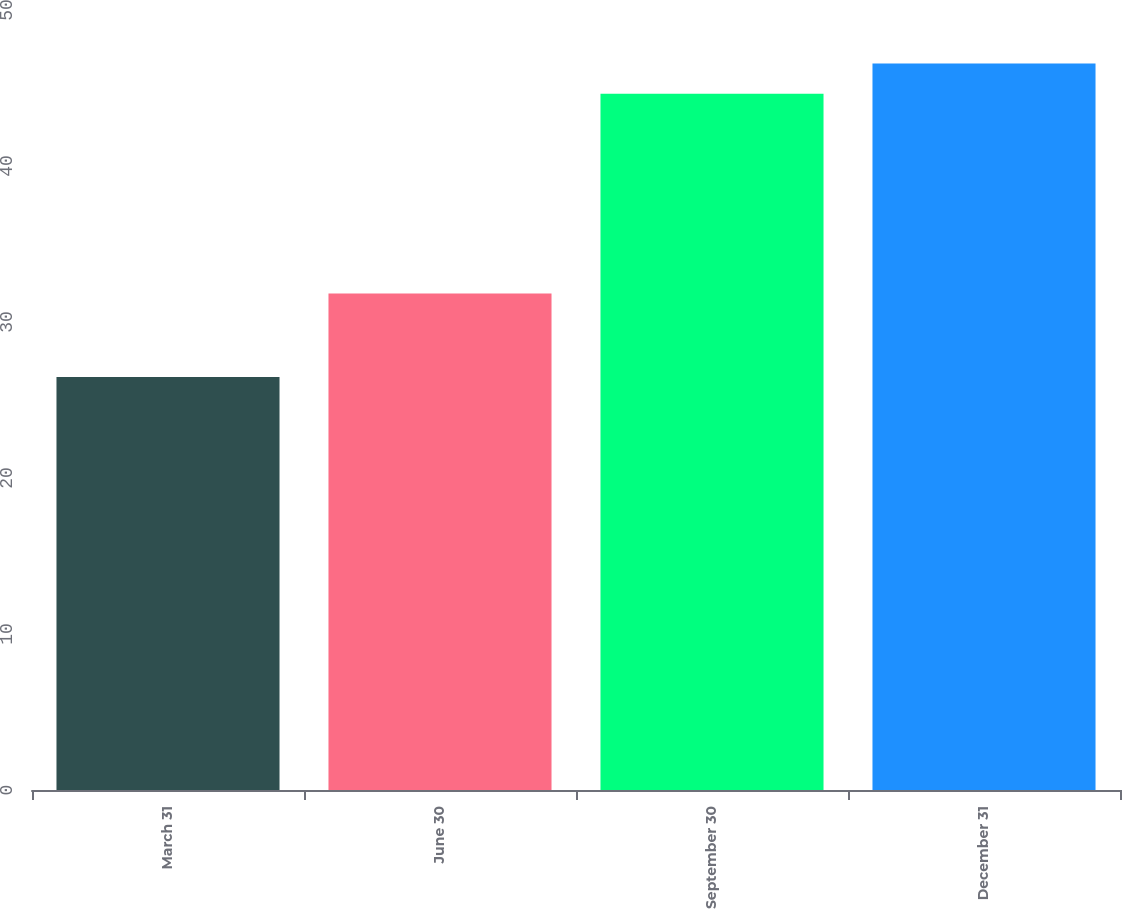Convert chart. <chart><loc_0><loc_0><loc_500><loc_500><bar_chart><fcel>March 31<fcel>June 30<fcel>September 30<fcel>December 31<nl><fcel>26.48<fcel>31.82<fcel>44.63<fcel>46.57<nl></chart> 